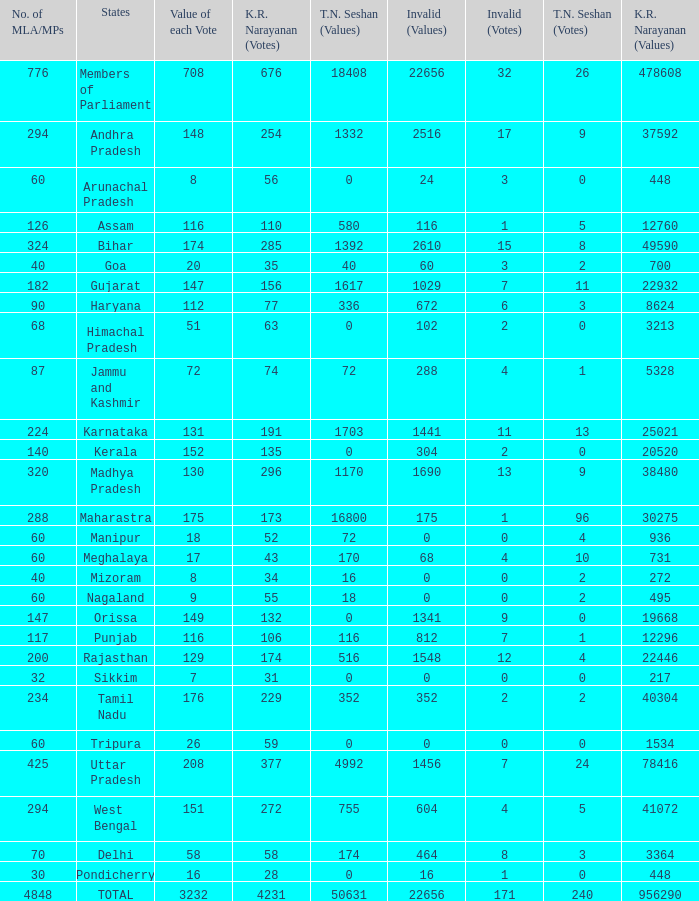Name the most kr votes for value of each vote for 208 377.0. 